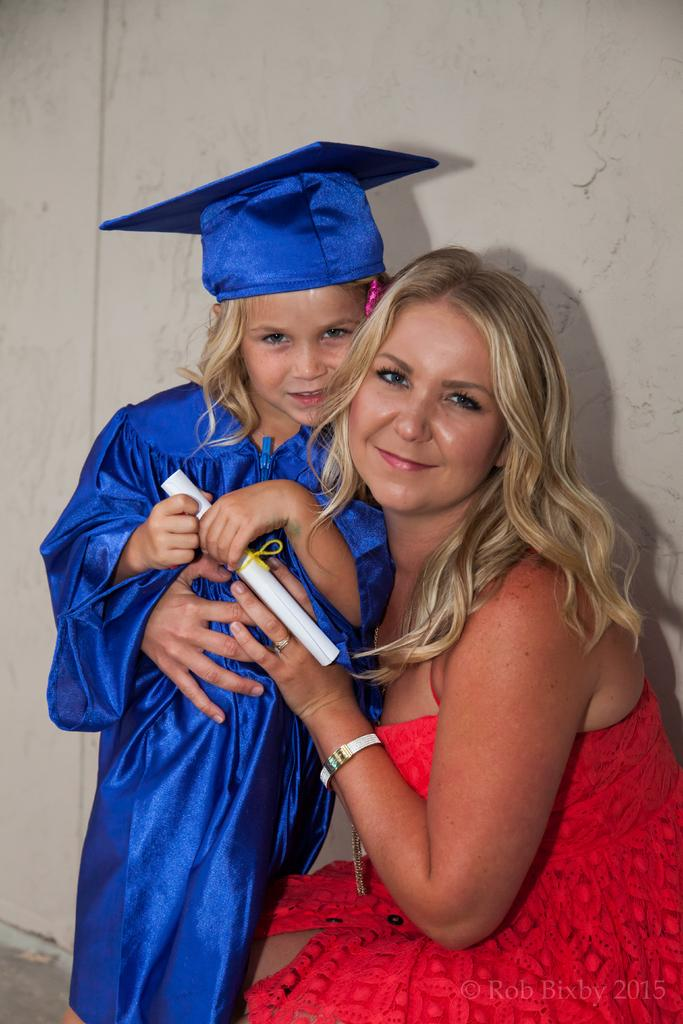Who is present in the image? There is a woman and a child in the image. What is the woman wearing? The woman is wearing a red dress. What is the child wearing? The child is wearing a blue dress. What is the child holding in their hands? The child is holding a paper in their hands. What can be seen in the background of the image? There is a wall visible in the background of the image. What type of needle is the woman using to sew the child's dress in the image? There is no needle present in the image, and the woman is not sewing the child's dress. How many friends are visible in the image? There are no friends visible in the image; only the woman and the child are present. 